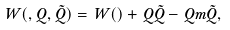<formula> <loc_0><loc_0><loc_500><loc_500>W ( \Phi , Q , \tilde { Q } ) = W ( \Phi ) + \Phi Q \tilde { Q } - Q m \tilde { Q } ,</formula> 